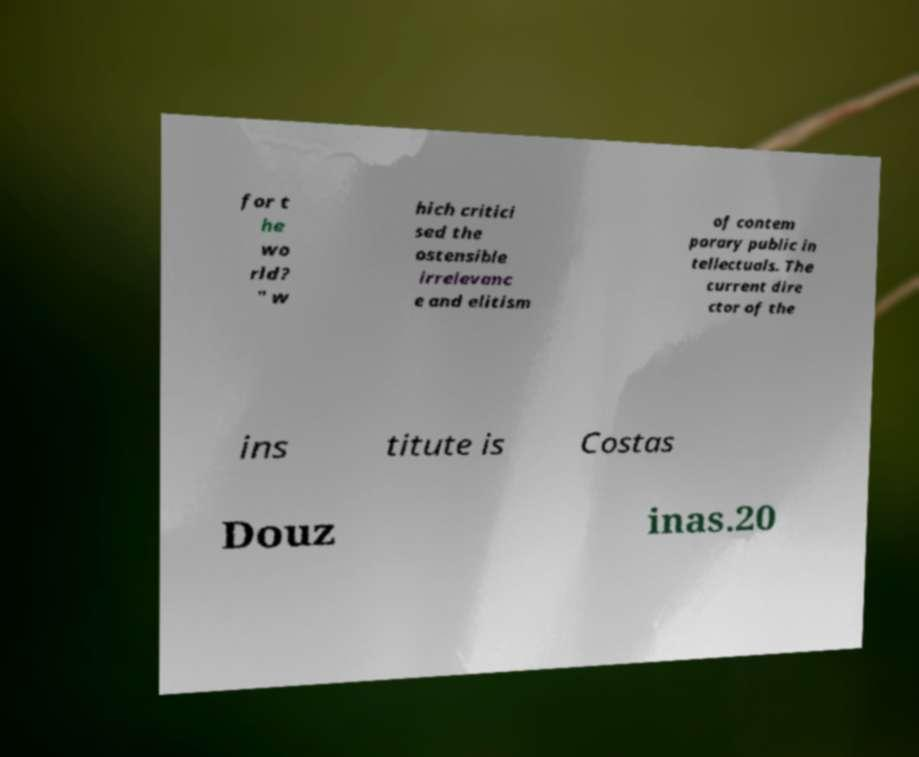Please read and relay the text visible in this image. What does it say? for t he wo rld? " w hich critici sed the ostensible irrelevanc e and elitism of contem porary public in tellectuals. The current dire ctor of the ins titute is Costas Douz inas.20 